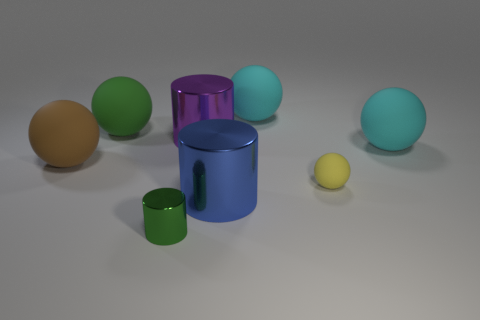Is there anything else that has the same material as the large brown object?
Make the answer very short. Yes. Is the color of the tiny metal thing the same as the tiny matte object?
Provide a short and direct response. No. What is the shape of the tiny thing that is to the right of the cylinder behind the small sphere?
Provide a succinct answer. Sphere. There is a green thing that is made of the same material as the purple cylinder; what shape is it?
Give a very brief answer. Cylinder. What number of other objects are there of the same shape as the purple thing?
Ensure brevity in your answer.  2. Does the green object in front of the blue metallic thing have the same size as the yellow rubber ball?
Give a very brief answer. Yes. Is the number of big cyan matte objects that are behind the purple object greater than the number of large purple metal cylinders?
Your answer should be very brief. No. What number of big purple cylinders are on the left side of the big cyan thing on the right side of the tiny matte thing?
Make the answer very short. 1. Is the number of big things that are left of the large blue metal thing less than the number of tiny green metal things?
Your answer should be compact. No. Are there any spheres that are left of the big matte ball right of the thing behind the big green rubber ball?
Offer a very short reply. Yes. 